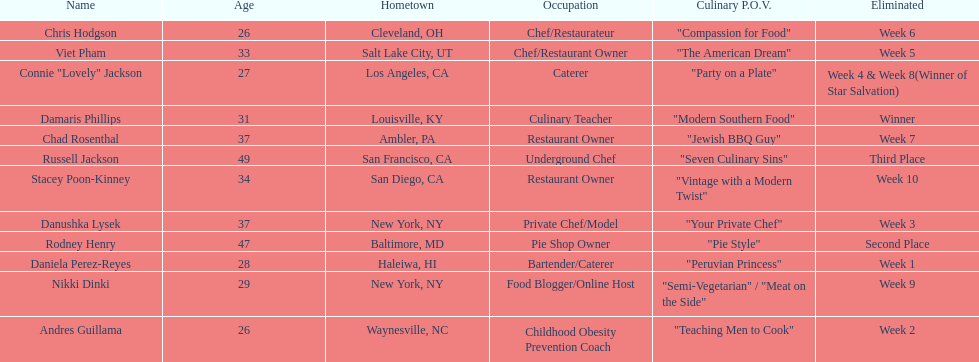Which contestant's culinary point of view had a longer description than "vintage with a modern twist"? Nikki Dinki. 